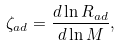Convert formula to latex. <formula><loc_0><loc_0><loc_500><loc_500>\zeta _ { a d } = \frac { d \ln R _ { a d } } { d \ln M } ,</formula> 